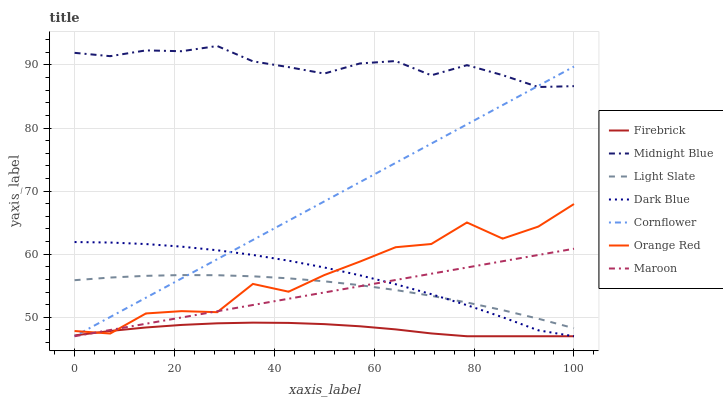Does Light Slate have the minimum area under the curve?
Answer yes or no. No. Does Light Slate have the maximum area under the curve?
Answer yes or no. No. Is Midnight Blue the smoothest?
Answer yes or no. No. Is Midnight Blue the roughest?
Answer yes or no. No. Does Light Slate have the lowest value?
Answer yes or no. No. Does Light Slate have the highest value?
Answer yes or no. No. Is Maroon less than Midnight Blue?
Answer yes or no. Yes. Is Midnight Blue greater than Dark Blue?
Answer yes or no. Yes. Does Maroon intersect Midnight Blue?
Answer yes or no. No. 